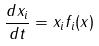<formula> <loc_0><loc_0><loc_500><loc_500>\frac { d x _ { i } } { d t } = x _ { i } f _ { i } ( x )</formula> 